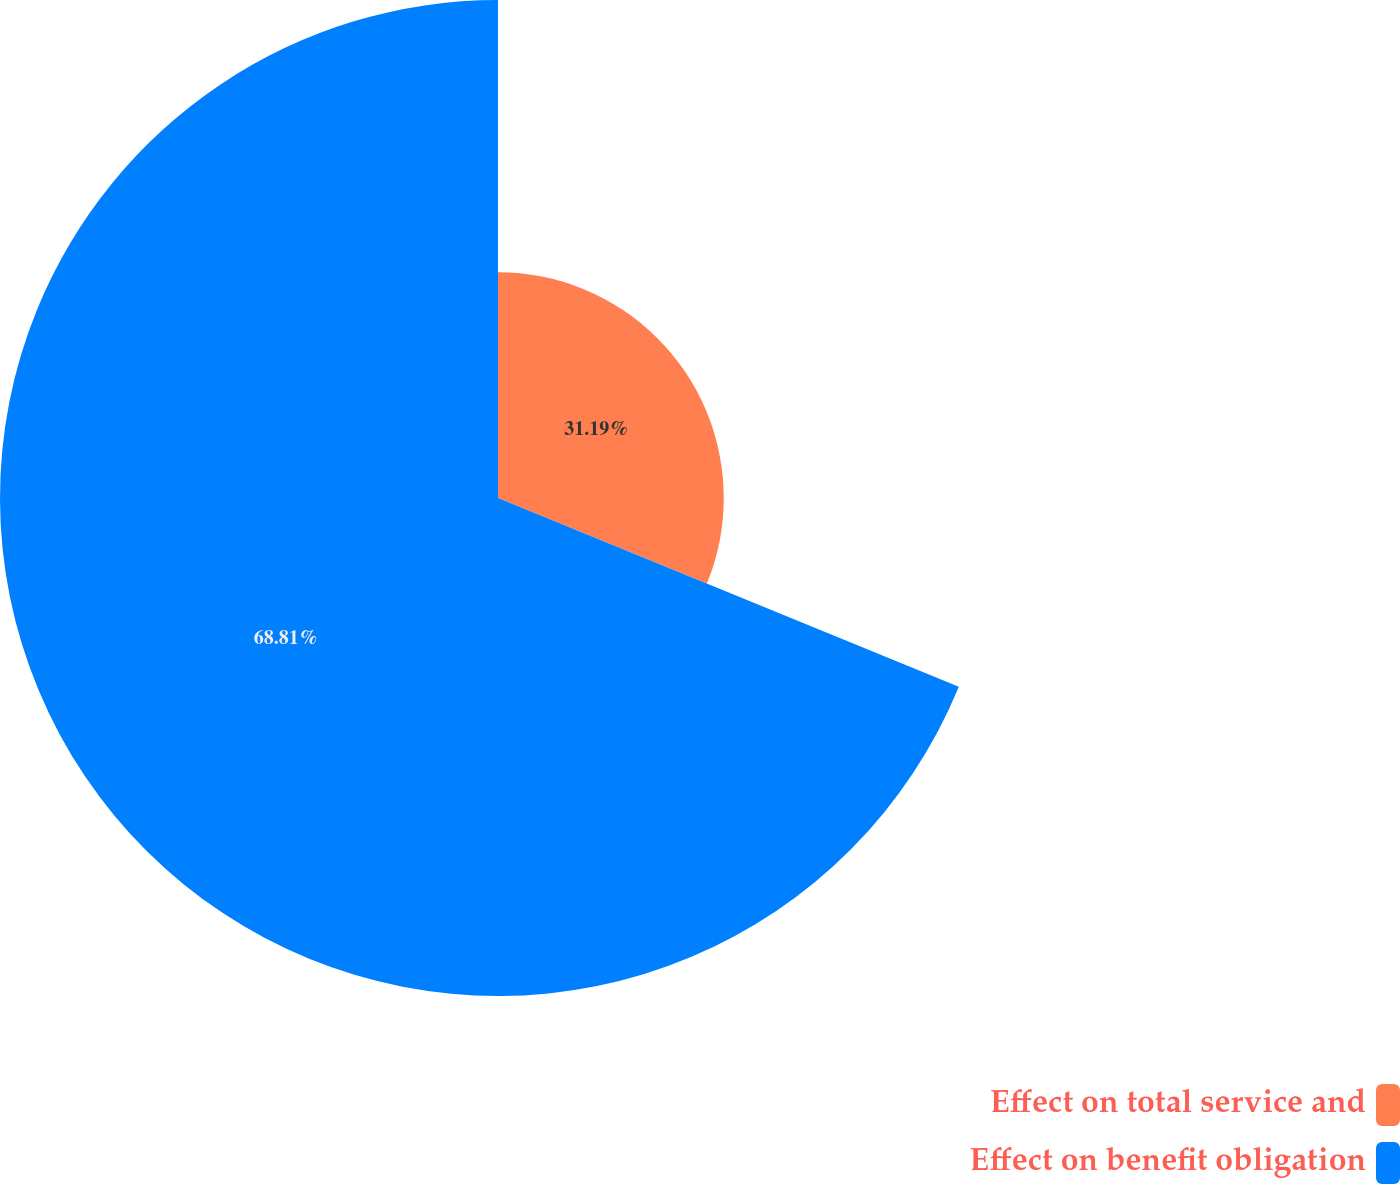Convert chart to OTSL. <chart><loc_0><loc_0><loc_500><loc_500><pie_chart><fcel>Effect on total service and<fcel>Effect on benefit obligation<nl><fcel>31.19%<fcel>68.81%<nl></chart> 